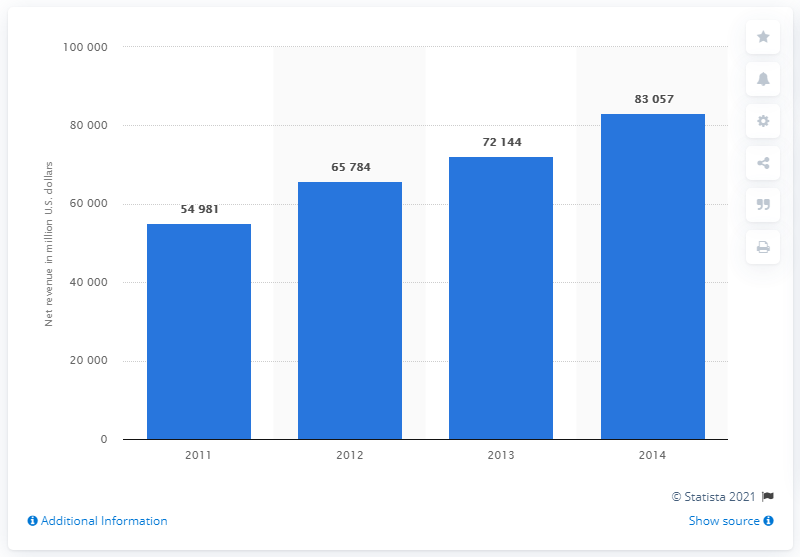List a handful of essential elements in this visual. In the fiscal year of 2011, Chrysler's fiscal year was 2013. FCA US LLC's net revenue in 2014 was approximately 83,057. 